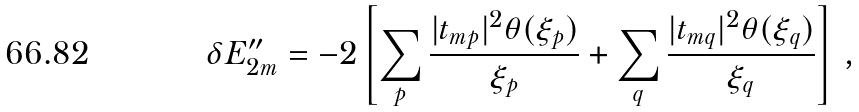<formula> <loc_0><loc_0><loc_500><loc_500>\delta E ^ { \prime \prime } _ { 2 m } = - 2 \left [ \sum _ { p } \frac { | t _ { m p } | ^ { 2 } \theta ( \xi _ { p } ) } { \xi _ { p } } + \sum _ { q } \frac { | t _ { m q } | ^ { 2 } \theta ( \xi _ { q } ) } { \xi _ { q } } \right ] \, ,</formula> 